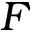<formula> <loc_0><loc_0><loc_500><loc_500>F</formula> 